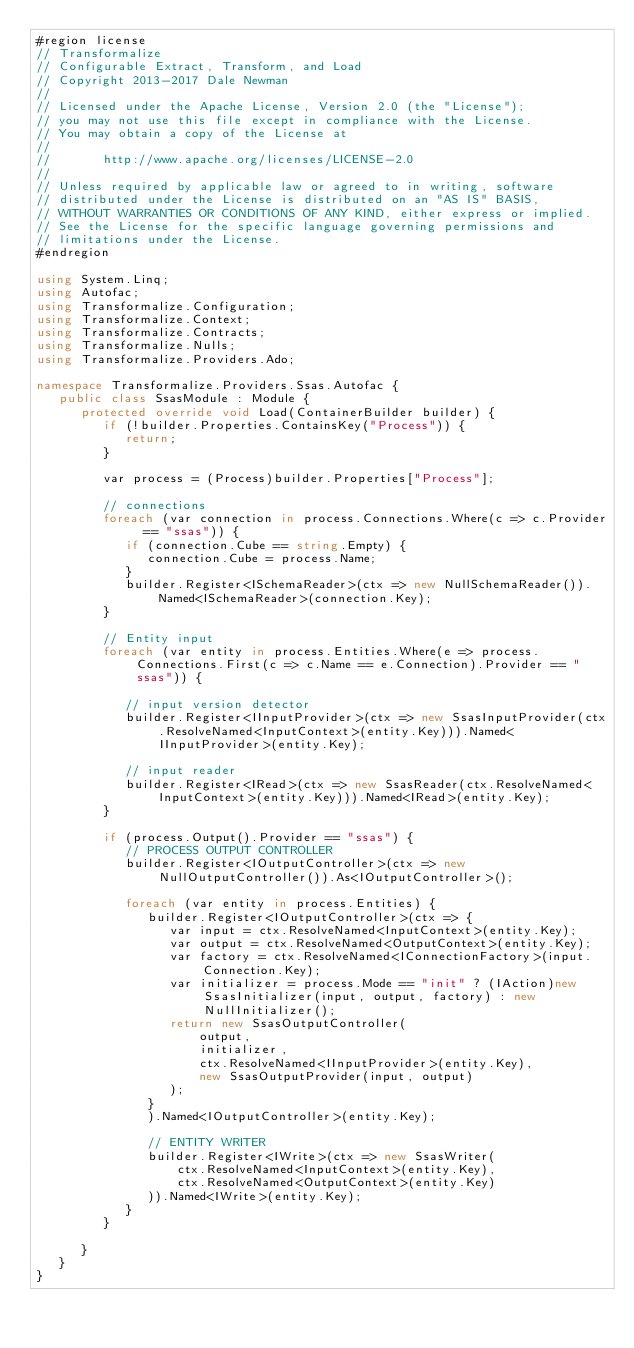<code> <loc_0><loc_0><loc_500><loc_500><_C#_>#region license
// Transformalize
// Configurable Extract, Transform, and Load
// Copyright 2013-2017 Dale Newman
//  
// Licensed under the Apache License, Version 2.0 (the "License");
// you may not use this file except in compliance with the License.
// You may obtain a copy of the License at
//   
//       http://www.apache.org/licenses/LICENSE-2.0
//   
// Unless required by applicable law or agreed to in writing, software
// distributed under the License is distributed on an "AS IS" BASIS,
// WITHOUT WARRANTIES OR CONDITIONS OF ANY KIND, either express or implied.
// See the License for the specific language governing permissions and
// limitations under the License.
#endregion

using System.Linq;
using Autofac;
using Transformalize.Configuration;
using Transformalize.Context;
using Transformalize.Contracts;
using Transformalize.Nulls;
using Transformalize.Providers.Ado;

namespace Transformalize.Providers.Ssas.Autofac {
   public class SsasModule : Module {
      protected override void Load(ContainerBuilder builder) {
         if (!builder.Properties.ContainsKey("Process")) {
            return;
         }

         var process = (Process)builder.Properties["Process"];

         // connections
         foreach (var connection in process.Connections.Where(c => c.Provider == "ssas")) {
            if (connection.Cube == string.Empty) {
               connection.Cube = process.Name;
            }
            builder.Register<ISchemaReader>(ctx => new NullSchemaReader()).Named<ISchemaReader>(connection.Key);
         }

         // Entity input
         foreach (var entity in process.Entities.Where(e => process.Connections.First(c => c.Name == e.Connection).Provider == "ssas")) {

            // input version detector
            builder.Register<IInputProvider>(ctx => new SsasInputProvider(ctx.ResolveNamed<InputContext>(entity.Key))).Named<IInputProvider>(entity.Key);

            // input reader
            builder.Register<IRead>(ctx => new SsasReader(ctx.ResolveNamed<InputContext>(entity.Key))).Named<IRead>(entity.Key);
         }

         if (process.Output().Provider == "ssas") {
            // PROCESS OUTPUT CONTROLLER
            builder.Register<IOutputController>(ctx => new NullOutputController()).As<IOutputController>();

            foreach (var entity in process.Entities) {
               builder.Register<IOutputController>(ctx => {
                  var input = ctx.ResolveNamed<InputContext>(entity.Key);
                  var output = ctx.ResolveNamed<OutputContext>(entity.Key);
                  var factory = ctx.ResolveNamed<IConnectionFactory>(input.Connection.Key);
                  var initializer = process.Mode == "init" ? (IAction)new SsasInitializer(input, output, factory) : new NullInitializer();
                  return new SsasOutputController(
                      output,
                      initializer,
                      ctx.ResolveNamed<IInputProvider>(entity.Key),
                      new SsasOutputProvider(input, output)
                  );
               }
               ).Named<IOutputController>(entity.Key);

               // ENTITY WRITER
               builder.Register<IWrite>(ctx => new SsasWriter(
                   ctx.ResolveNamed<InputContext>(entity.Key),
                   ctx.ResolveNamed<OutputContext>(entity.Key)
               )).Named<IWrite>(entity.Key);
            }
         }

      }
   }
}</code> 